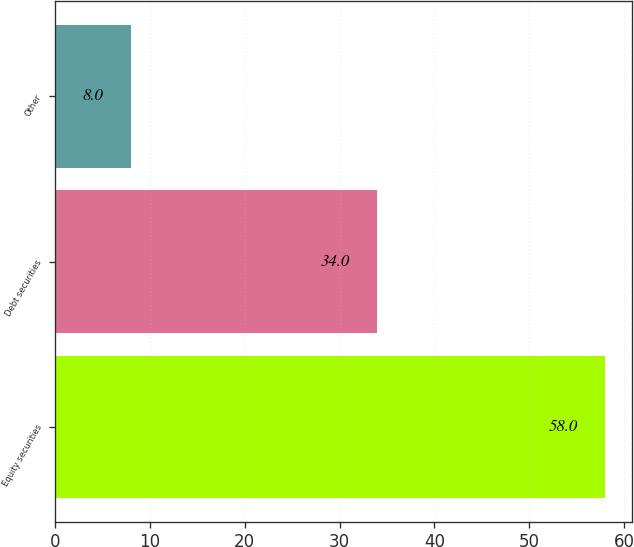Convert chart. <chart><loc_0><loc_0><loc_500><loc_500><bar_chart><fcel>Equity securities<fcel>Debt securities<fcel>Other<nl><fcel>58<fcel>34<fcel>8<nl></chart> 